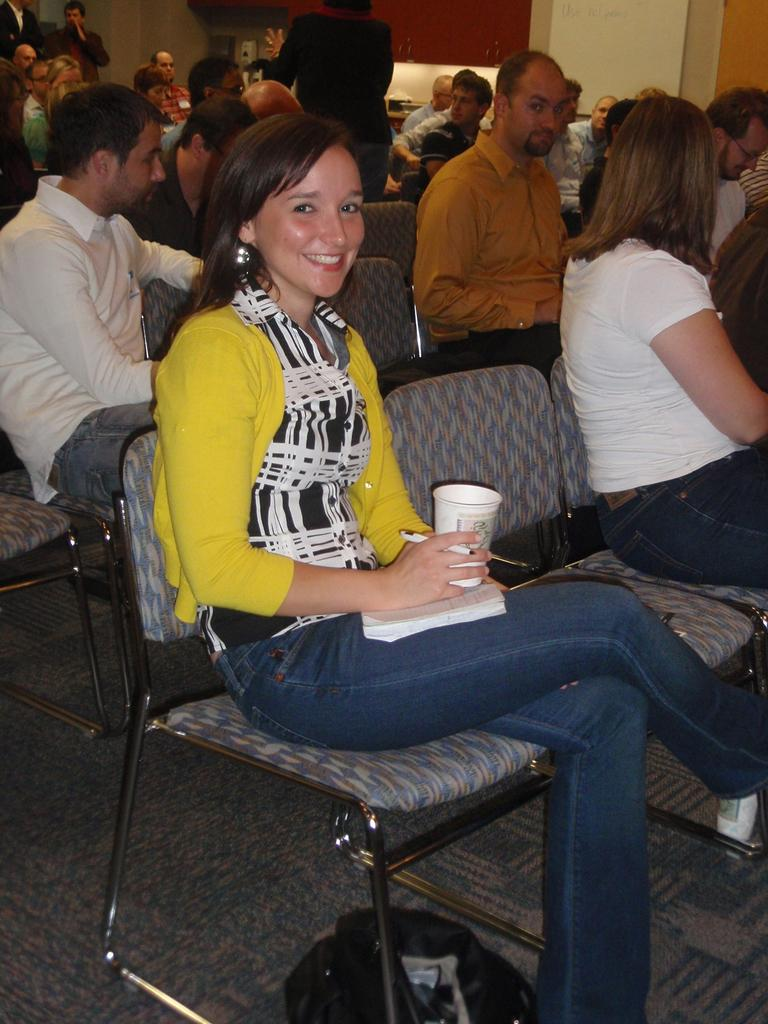What is the woman in the image doing? The woman is sitting on a chair in the image. What is the woman's facial expression? The woman is smiling in the image. What is the woman holding in her hand? The woman is holding a glass in her hand. Can you describe the group of people in the image? There are people sitting in a group in the image. What is the position of the other woman in the image? There is a woman standing in the image. What type of crack is visible on the woman's face in the image? There is no crack visible on the woman's face in the image. 